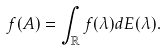<formula> <loc_0><loc_0><loc_500><loc_500>f ( A ) = \int _ { \mathbb { R } } f ( \lambda ) d E ( \lambda ) .</formula> 